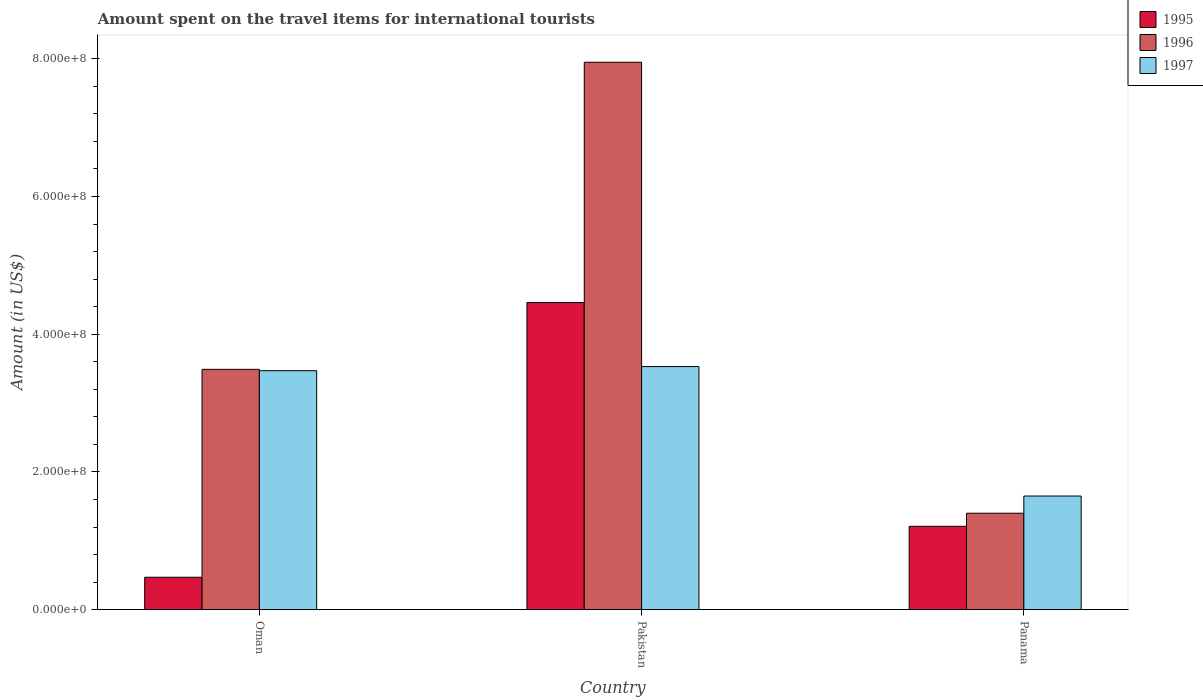How many groups of bars are there?
Your answer should be compact. 3. Are the number of bars per tick equal to the number of legend labels?
Provide a short and direct response. Yes. Are the number of bars on each tick of the X-axis equal?
Ensure brevity in your answer.  Yes. How many bars are there on the 1st tick from the left?
Your answer should be very brief. 3. What is the label of the 1st group of bars from the left?
Provide a short and direct response. Oman. In how many cases, is the number of bars for a given country not equal to the number of legend labels?
Offer a terse response. 0. What is the amount spent on the travel items for international tourists in 1995 in Panama?
Offer a terse response. 1.21e+08. Across all countries, what is the maximum amount spent on the travel items for international tourists in 1996?
Your answer should be very brief. 7.95e+08. Across all countries, what is the minimum amount spent on the travel items for international tourists in 1997?
Offer a very short reply. 1.65e+08. In which country was the amount spent on the travel items for international tourists in 1997 maximum?
Make the answer very short. Pakistan. In which country was the amount spent on the travel items for international tourists in 1997 minimum?
Offer a very short reply. Panama. What is the total amount spent on the travel items for international tourists in 1996 in the graph?
Your response must be concise. 1.28e+09. What is the difference between the amount spent on the travel items for international tourists in 1996 in Oman and that in Panama?
Offer a terse response. 2.09e+08. What is the difference between the amount spent on the travel items for international tourists in 1997 in Oman and the amount spent on the travel items for international tourists in 1995 in Panama?
Give a very brief answer. 2.26e+08. What is the average amount spent on the travel items for international tourists in 1996 per country?
Offer a very short reply. 4.28e+08. What is the difference between the amount spent on the travel items for international tourists of/in 1997 and amount spent on the travel items for international tourists of/in 1996 in Oman?
Provide a succinct answer. -2.00e+06. What is the ratio of the amount spent on the travel items for international tourists in 1997 in Oman to that in Panama?
Make the answer very short. 2.1. Is the amount spent on the travel items for international tourists in 1995 in Oman less than that in Panama?
Give a very brief answer. Yes. What is the difference between the highest and the second highest amount spent on the travel items for international tourists in 1996?
Provide a succinct answer. 6.55e+08. What is the difference between the highest and the lowest amount spent on the travel items for international tourists in 1997?
Offer a terse response. 1.88e+08. In how many countries, is the amount spent on the travel items for international tourists in 1997 greater than the average amount spent on the travel items for international tourists in 1997 taken over all countries?
Provide a succinct answer. 2. What does the 1st bar from the left in Pakistan represents?
Offer a very short reply. 1995. Are all the bars in the graph horizontal?
Provide a succinct answer. No. How many countries are there in the graph?
Your answer should be very brief. 3. What is the difference between two consecutive major ticks on the Y-axis?
Provide a succinct answer. 2.00e+08. Does the graph contain any zero values?
Offer a terse response. No. Does the graph contain grids?
Ensure brevity in your answer.  No. Where does the legend appear in the graph?
Provide a succinct answer. Top right. What is the title of the graph?
Ensure brevity in your answer.  Amount spent on the travel items for international tourists. Does "1983" appear as one of the legend labels in the graph?
Give a very brief answer. No. What is the label or title of the X-axis?
Keep it short and to the point. Country. What is the label or title of the Y-axis?
Your answer should be compact. Amount (in US$). What is the Amount (in US$) of 1995 in Oman?
Your answer should be compact. 4.70e+07. What is the Amount (in US$) of 1996 in Oman?
Offer a terse response. 3.49e+08. What is the Amount (in US$) of 1997 in Oman?
Your response must be concise. 3.47e+08. What is the Amount (in US$) in 1995 in Pakistan?
Ensure brevity in your answer.  4.46e+08. What is the Amount (in US$) in 1996 in Pakistan?
Your response must be concise. 7.95e+08. What is the Amount (in US$) of 1997 in Pakistan?
Provide a short and direct response. 3.53e+08. What is the Amount (in US$) in 1995 in Panama?
Your answer should be compact. 1.21e+08. What is the Amount (in US$) in 1996 in Panama?
Provide a short and direct response. 1.40e+08. What is the Amount (in US$) of 1997 in Panama?
Your answer should be compact. 1.65e+08. Across all countries, what is the maximum Amount (in US$) of 1995?
Provide a short and direct response. 4.46e+08. Across all countries, what is the maximum Amount (in US$) in 1996?
Your answer should be very brief. 7.95e+08. Across all countries, what is the maximum Amount (in US$) in 1997?
Offer a very short reply. 3.53e+08. Across all countries, what is the minimum Amount (in US$) of 1995?
Make the answer very short. 4.70e+07. Across all countries, what is the minimum Amount (in US$) in 1996?
Provide a short and direct response. 1.40e+08. Across all countries, what is the minimum Amount (in US$) of 1997?
Provide a succinct answer. 1.65e+08. What is the total Amount (in US$) of 1995 in the graph?
Your answer should be very brief. 6.14e+08. What is the total Amount (in US$) in 1996 in the graph?
Provide a succinct answer. 1.28e+09. What is the total Amount (in US$) in 1997 in the graph?
Your answer should be very brief. 8.65e+08. What is the difference between the Amount (in US$) in 1995 in Oman and that in Pakistan?
Offer a terse response. -3.99e+08. What is the difference between the Amount (in US$) in 1996 in Oman and that in Pakistan?
Offer a terse response. -4.46e+08. What is the difference between the Amount (in US$) of 1997 in Oman and that in Pakistan?
Ensure brevity in your answer.  -6.00e+06. What is the difference between the Amount (in US$) in 1995 in Oman and that in Panama?
Ensure brevity in your answer.  -7.40e+07. What is the difference between the Amount (in US$) of 1996 in Oman and that in Panama?
Offer a very short reply. 2.09e+08. What is the difference between the Amount (in US$) of 1997 in Oman and that in Panama?
Give a very brief answer. 1.82e+08. What is the difference between the Amount (in US$) of 1995 in Pakistan and that in Panama?
Ensure brevity in your answer.  3.25e+08. What is the difference between the Amount (in US$) of 1996 in Pakistan and that in Panama?
Offer a terse response. 6.55e+08. What is the difference between the Amount (in US$) in 1997 in Pakistan and that in Panama?
Provide a succinct answer. 1.88e+08. What is the difference between the Amount (in US$) in 1995 in Oman and the Amount (in US$) in 1996 in Pakistan?
Give a very brief answer. -7.48e+08. What is the difference between the Amount (in US$) in 1995 in Oman and the Amount (in US$) in 1997 in Pakistan?
Your answer should be very brief. -3.06e+08. What is the difference between the Amount (in US$) in 1996 in Oman and the Amount (in US$) in 1997 in Pakistan?
Give a very brief answer. -4.00e+06. What is the difference between the Amount (in US$) of 1995 in Oman and the Amount (in US$) of 1996 in Panama?
Your answer should be very brief. -9.30e+07. What is the difference between the Amount (in US$) of 1995 in Oman and the Amount (in US$) of 1997 in Panama?
Provide a short and direct response. -1.18e+08. What is the difference between the Amount (in US$) of 1996 in Oman and the Amount (in US$) of 1997 in Panama?
Give a very brief answer. 1.84e+08. What is the difference between the Amount (in US$) in 1995 in Pakistan and the Amount (in US$) in 1996 in Panama?
Your answer should be compact. 3.06e+08. What is the difference between the Amount (in US$) of 1995 in Pakistan and the Amount (in US$) of 1997 in Panama?
Give a very brief answer. 2.81e+08. What is the difference between the Amount (in US$) of 1996 in Pakistan and the Amount (in US$) of 1997 in Panama?
Your answer should be compact. 6.30e+08. What is the average Amount (in US$) of 1995 per country?
Provide a succinct answer. 2.05e+08. What is the average Amount (in US$) in 1996 per country?
Your answer should be very brief. 4.28e+08. What is the average Amount (in US$) in 1997 per country?
Keep it short and to the point. 2.88e+08. What is the difference between the Amount (in US$) of 1995 and Amount (in US$) of 1996 in Oman?
Your answer should be very brief. -3.02e+08. What is the difference between the Amount (in US$) of 1995 and Amount (in US$) of 1997 in Oman?
Make the answer very short. -3.00e+08. What is the difference between the Amount (in US$) of 1995 and Amount (in US$) of 1996 in Pakistan?
Your response must be concise. -3.49e+08. What is the difference between the Amount (in US$) of 1995 and Amount (in US$) of 1997 in Pakistan?
Offer a very short reply. 9.30e+07. What is the difference between the Amount (in US$) of 1996 and Amount (in US$) of 1997 in Pakistan?
Your answer should be very brief. 4.42e+08. What is the difference between the Amount (in US$) of 1995 and Amount (in US$) of 1996 in Panama?
Ensure brevity in your answer.  -1.90e+07. What is the difference between the Amount (in US$) in 1995 and Amount (in US$) in 1997 in Panama?
Keep it short and to the point. -4.40e+07. What is the difference between the Amount (in US$) of 1996 and Amount (in US$) of 1997 in Panama?
Provide a succinct answer. -2.50e+07. What is the ratio of the Amount (in US$) in 1995 in Oman to that in Pakistan?
Your answer should be compact. 0.11. What is the ratio of the Amount (in US$) in 1996 in Oman to that in Pakistan?
Keep it short and to the point. 0.44. What is the ratio of the Amount (in US$) of 1997 in Oman to that in Pakistan?
Ensure brevity in your answer.  0.98. What is the ratio of the Amount (in US$) of 1995 in Oman to that in Panama?
Make the answer very short. 0.39. What is the ratio of the Amount (in US$) in 1996 in Oman to that in Panama?
Your answer should be compact. 2.49. What is the ratio of the Amount (in US$) of 1997 in Oman to that in Panama?
Your answer should be very brief. 2.1. What is the ratio of the Amount (in US$) of 1995 in Pakistan to that in Panama?
Your response must be concise. 3.69. What is the ratio of the Amount (in US$) in 1996 in Pakistan to that in Panama?
Your response must be concise. 5.68. What is the ratio of the Amount (in US$) in 1997 in Pakistan to that in Panama?
Give a very brief answer. 2.14. What is the difference between the highest and the second highest Amount (in US$) of 1995?
Provide a short and direct response. 3.25e+08. What is the difference between the highest and the second highest Amount (in US$) in 1996?
Your response must be concise. 4.46e+08. What is the difference between the highest and the lowest Amount (in US$) in 1995?
Your answer should be compact. 3.99e+08. What is the difference between the highest and the lowest Amount (in US$) of 1996?
Your response must be concise. 6.55e+08. What is the difference between the highest and the lowest Amount (in US$) in 1997?
Make the answer very short. 1.88e+08. 